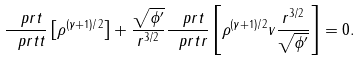Convert formula to latex. <formula><loc_0><loc_0><loc_500><loc_500>\frac { \ p r t } { \ p r t t } \left [ \rho ^ { ( \gamma + 1 ) / 2 } \right ] + \frac { \sqrt { \phi ^ { \prime } } } { r ^ { 3 / 2 } } \frac { \ p r t } { \ p r t r } \left [ \rho ^ { ( \gamma + 1 ) / 2 } v \frac { r ^ { 3 / 2 } } { \sqrt { \phi ^ { \prime } } } \right ] = 0 .</formula> 